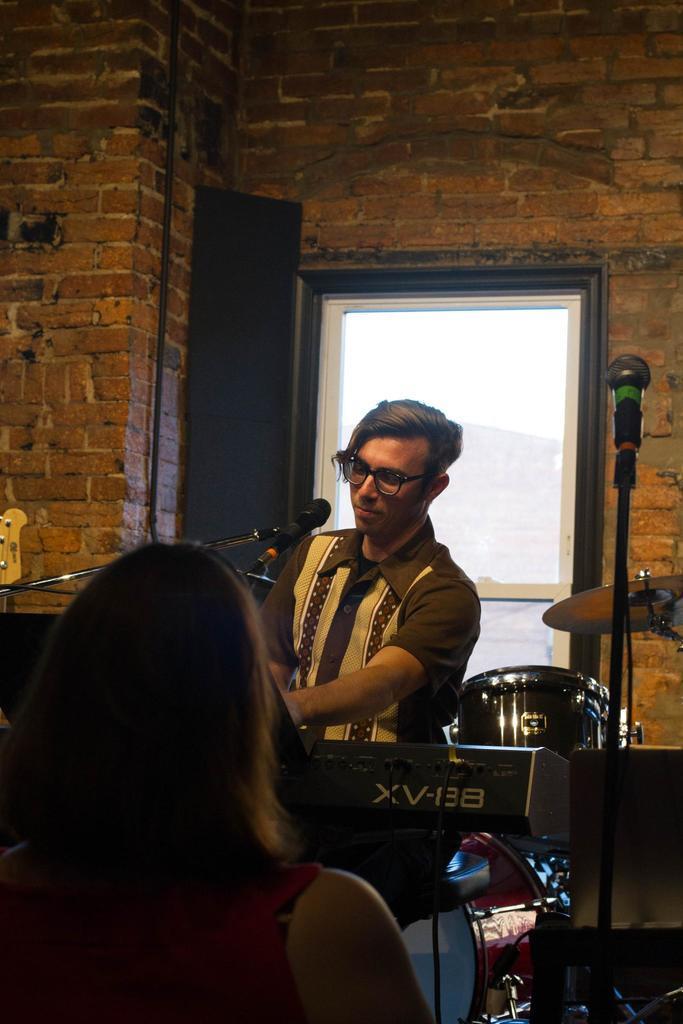Can you describe this image briefly? In this picture there are two people and we can see microphones with stands, musical instrument and device. In the background of the image we can see wall and glass. 